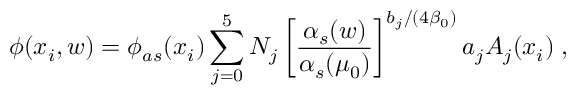Convert formula to latex. <formula><loc_0><loc_0><loc_500><loc_500>\phi ( x _ { i } , w ) = \phi _ { a s } ( x _ { i } ) \sum _ { j = 0 } ^ { 5 } N _ { j } \left [ \frac { \alpha _ { s } ( w ) } { \alpha _ { s } ( \mu _ { 0 } ) } \right ] ^ { b _ { j } / ( 4 \beta _ { 0 } ) } a _ { j } A _ { j } ( x _ { i } ) \, ,</formula> 